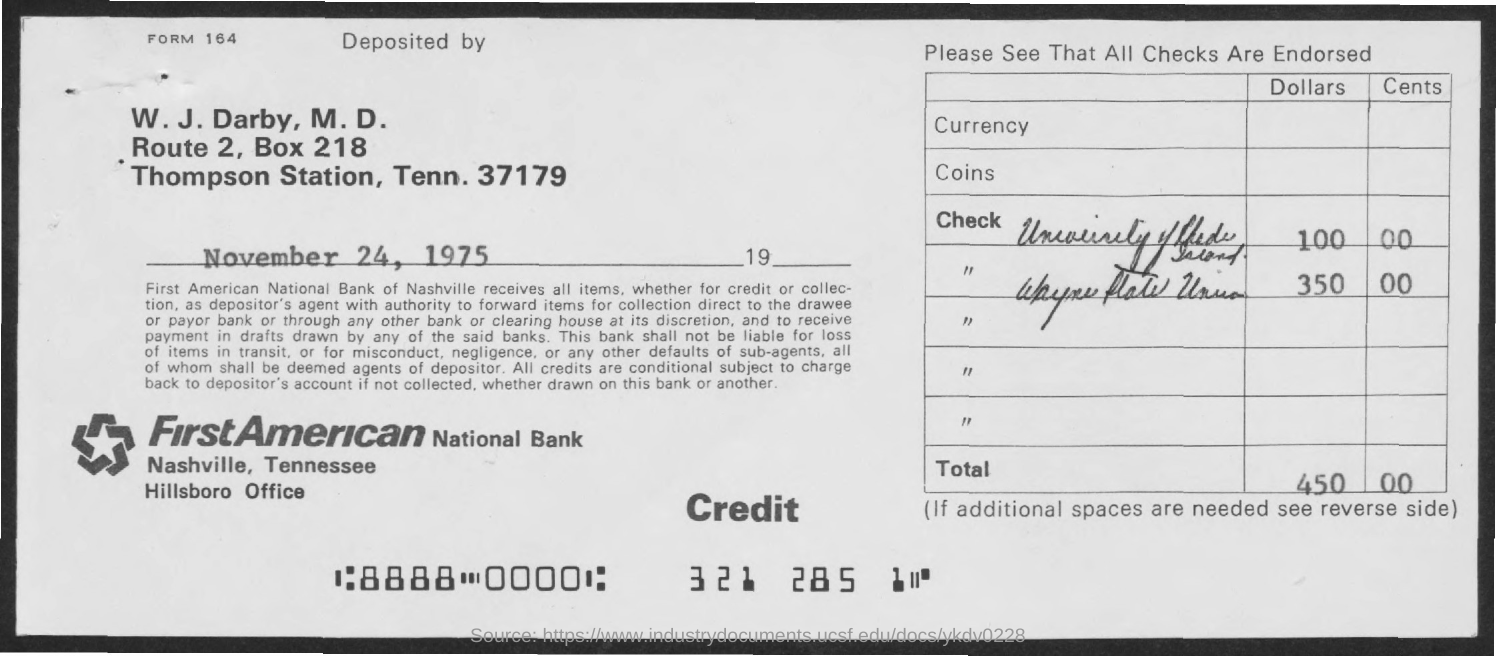What is the date of deposit?
Your answer should be very brief. November 24, 1975. What is the name of the bank?
Ensure brevity in your answer.  First American National Bank. What is the total amount of deposit?
Give a very brief answer. 450 00. What is the form no.?
Give a very brief answer. 164. What is the address of first american national bank?
Give a very brief answer. Nashville, Tennessee. 